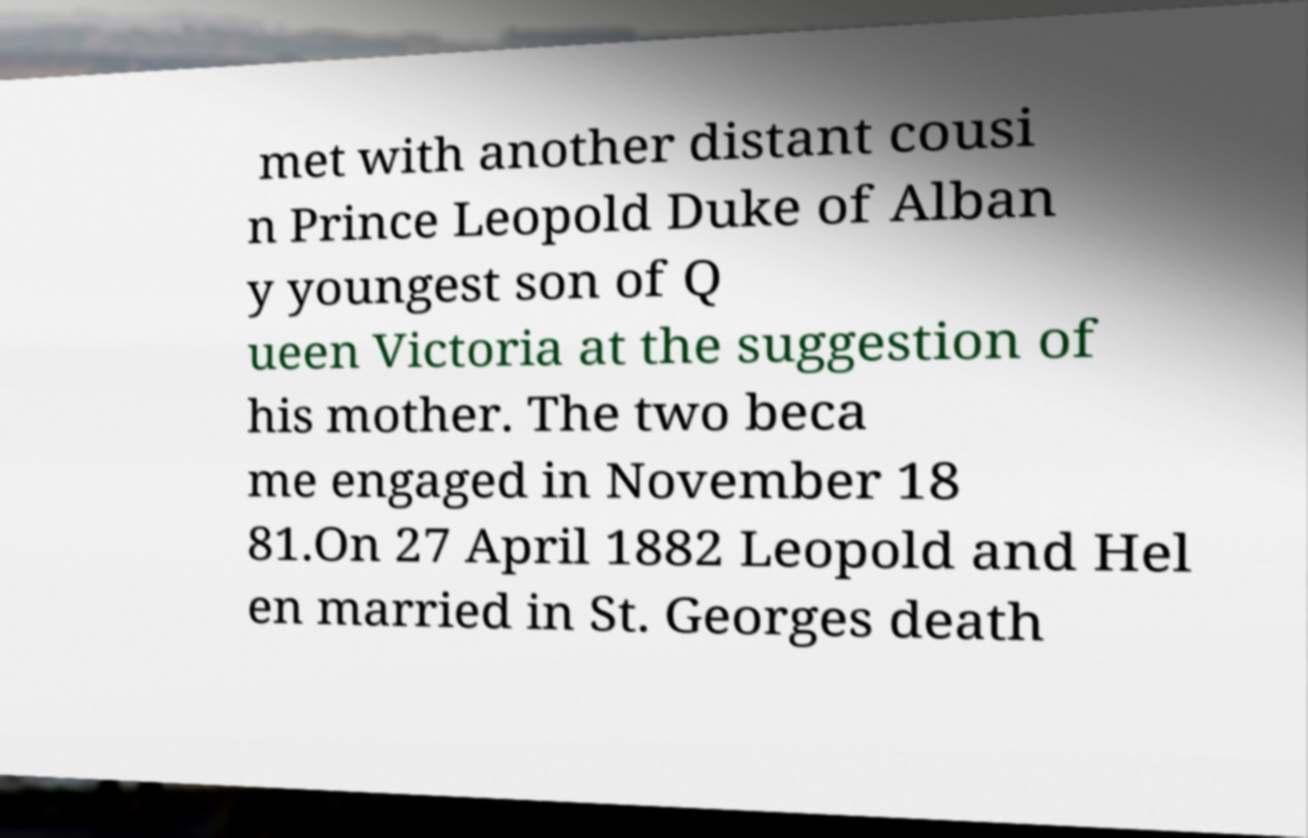Can you read and provide the text displayed in the image?This photo seems to have some interesting text. Can you extract and type it out for me? met with another distant cousi n Prince Leopold Duke of Alban y youngest son of Q ueen Victoria at the suggestion of his mother. The two beca me engaged in November 18 81.On 27 April 1882 Leopold and Hel en married in St. Georges death 